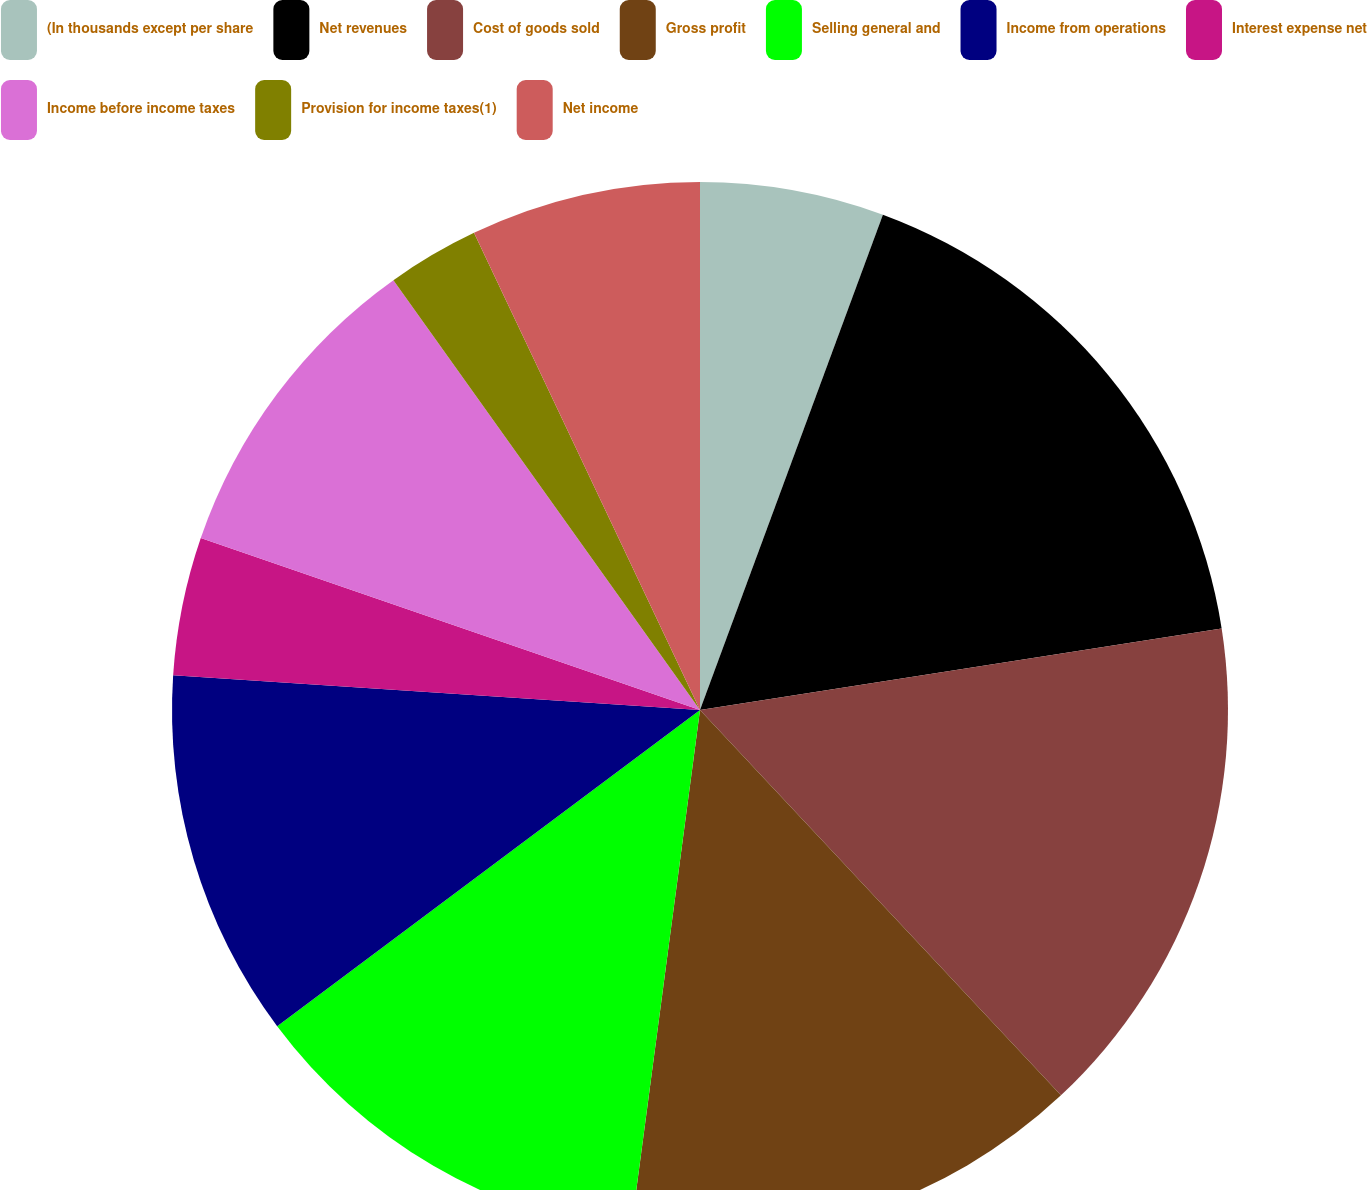Convert chart. <chart><loc_0><loc_0><loc_500><loc_500><pie_chart><fcel>(In thousands except per share<fcel>Net revenues<fcel>Cost of goods sold<fcel>Gross profit<fcel>Selling general and<fcel>Income from operations<fcel>Interest expense net<fcel>Income before income taxes<fcel>Provision for income taxes(1)<fcel>Net income<nl><fcel>5.63%<fcel>16.9%<fcel>15.49%<fcel>14.08%<fcel>12.68%<fcel>11.27%<fcel>4.23%<fcel>9.86%<fcel>2.82%<fcel>7.04%<nl></chart> 